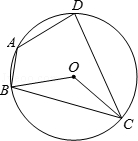How could you use this diagram to demonstrate the theorem about angles subtended by the same arc at different points on the circumference? This diagram is perfect for demonstrating that angles subtended by the same arc in a circle are equal. For instance, the arc subtending angle B and angle D from opposite ends should ensure that these angles are equal. This is a visual representation of a key circle theorem, which states that the angle subtended by an arc at the centre is twice the angle subtended by it at any other point on the circumference. 